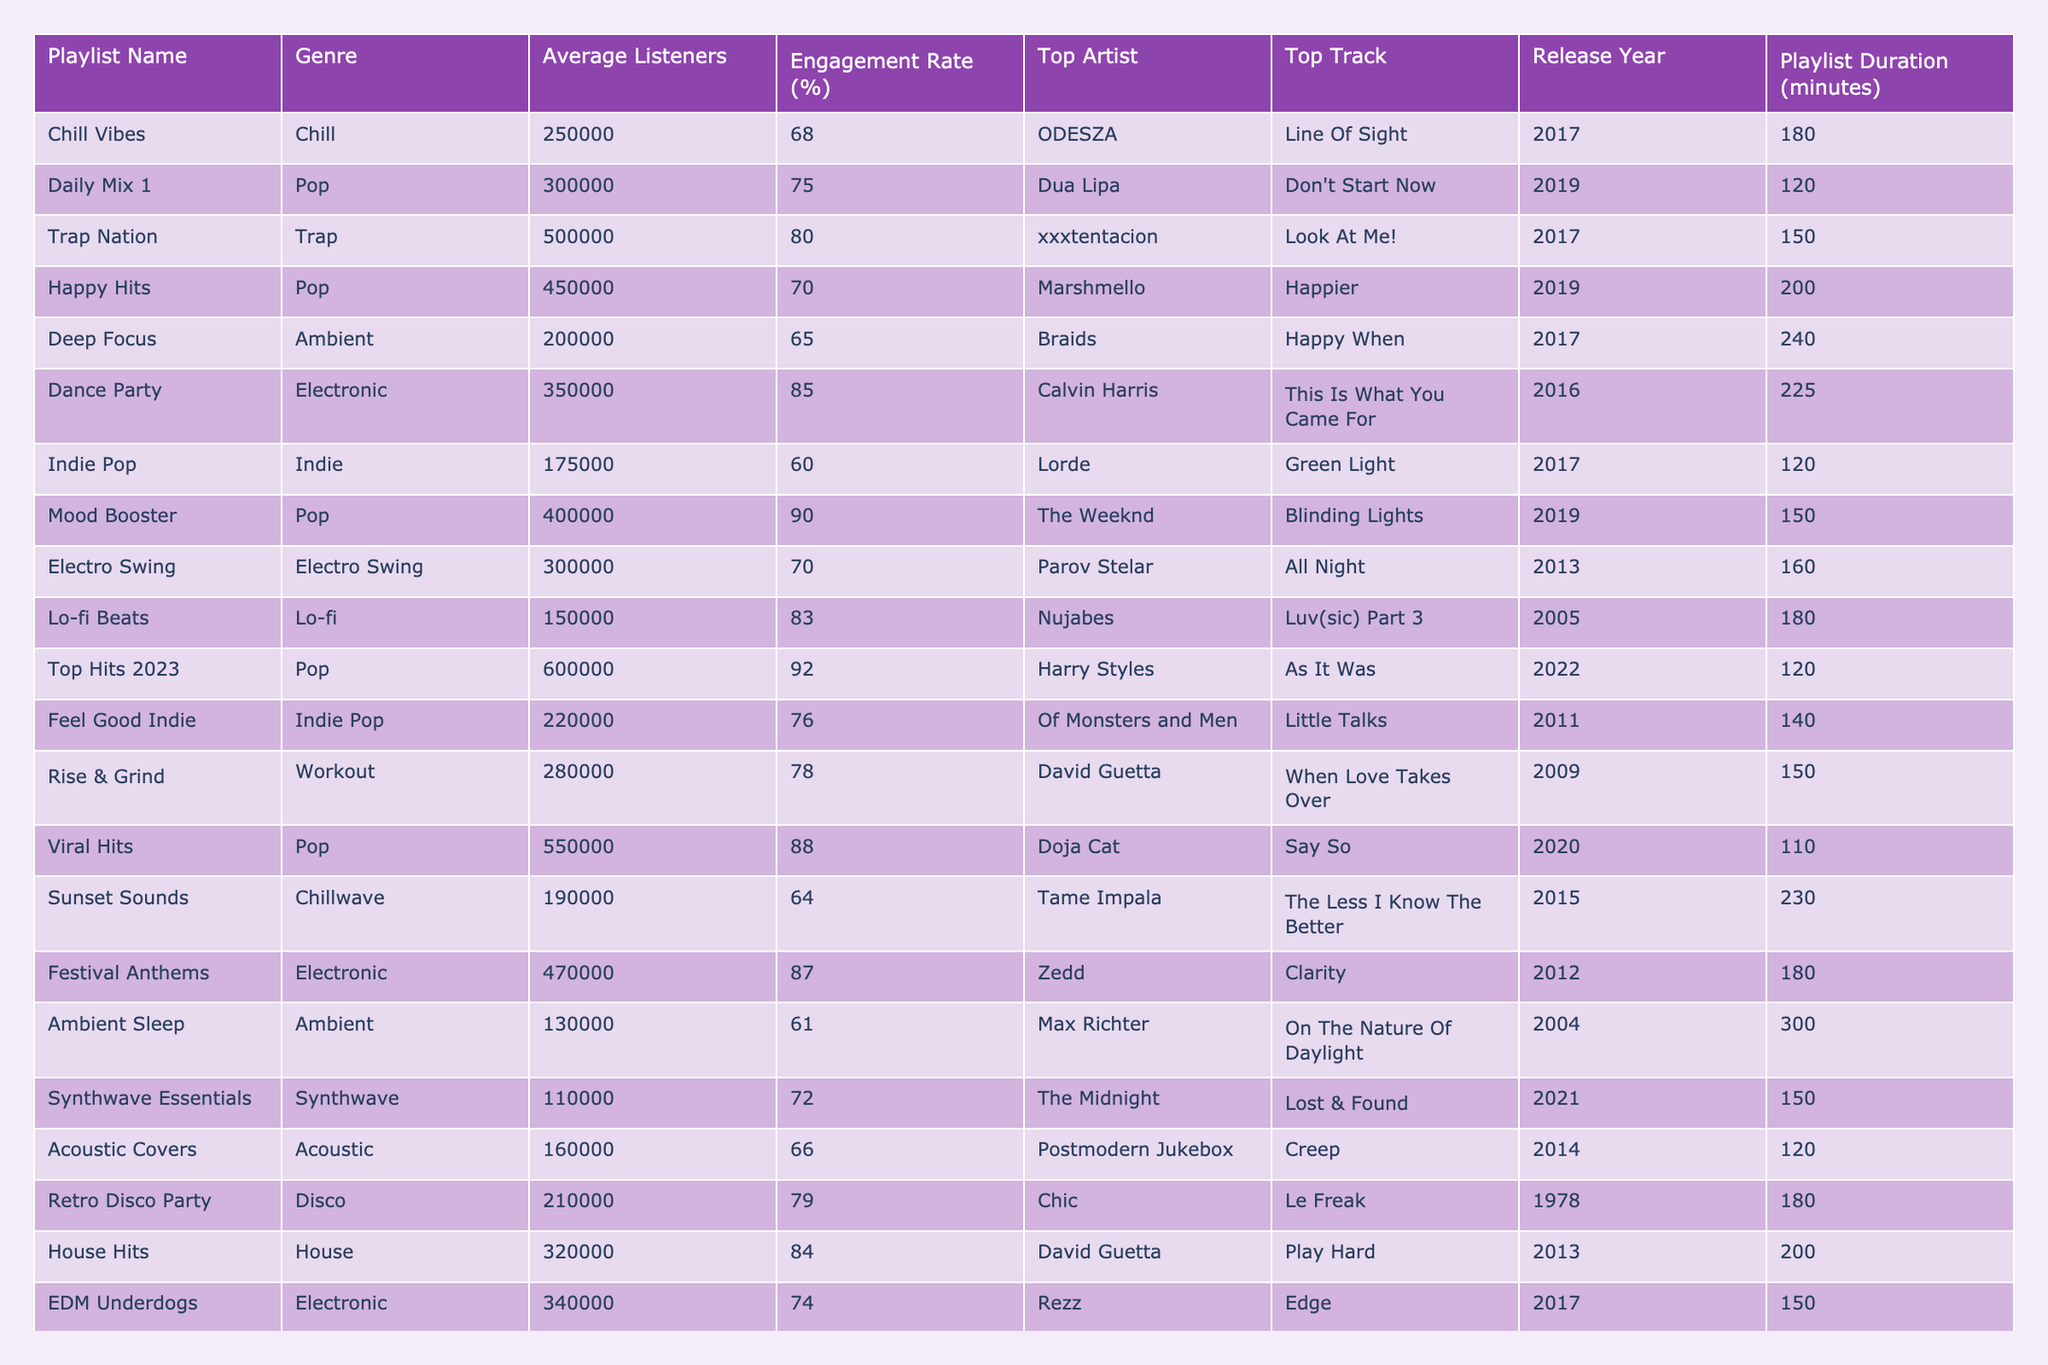What is the average engagement rate of all playlists listed? To find the average engagement rate, sum all the engagement rates (68 + 75 + 80 + 70 + 65 + 85 + 60 + 90 + 70 + 92 + 76 + 78 + 88 + 64 + 87 + 61 + 72 + 66 + 79 + 84 + 74) and divide by the number of playlists, which is 21. The total sum is 1470, so the average engagement rate is 1470 / 21 = 70.0%.
Answer: 70.0% Which playlist has the highest average listeners? By reviewing the "Average Listeners" column, I find that "Top Hits 2023" has the most at 600,000, making it the playlist with the highest average listeners.
Answer: Top Hits 2023 Is the "Mood Booster" playlist genre Pop? Checking the genre of the "Mood Booster" playlist, it is listed as Pop. Therefore, this statement is true.
Answer: True Which playlist has the longest duration and what is its length? By inspecting the "Playlist Duration" column, I see that "Ambient Sleep" has the longest duration at 300 minutes.
Answer: Ambient Sleep, 300 minutes What is the engagement rate difference between "Dance Party" and "Mood Booster"? The engagement rate for "Dance Party" is 85% and for "Mood Booster" it is 90%. The difference is 90 - 85 = 5%.
Answer: 5% Are there any playlists in the Chillwave genre? Looking through the genre column, I can see that there is one playlist named "Sunset Sounds" under the Chillwave genre, so the answer is yes.
Answer: Yes What is the total number of average listeners across all Electronic genre playlists? I calculate the total average listeners by adding the relevant playlists: "Dance Party" (350,000), "Festival Anthems" (470,000), and "EDM Underdogs" (340,000). The total is 350,000 + 470,000 + 340,000 = 1,160,000.
Answer: 1,160,000 Which artist appears most frequently as the top artist in the playlists? By comparing the "Top Artist" entries, I see that David Guetta appears twice: in "Rise & Grind" and "House Hits," making him the most frequently appearing top artist.
Answer: David Guetta What is the average duration of playlists in the Indie genre? The playlists in the Indie genre are "Indie Pop" (120), "Feel Good Indie" (140), and the average duration is (120 + 140) / 2 = 130 minutes.
Answer: 130 minutes What per cent of all playlists have an engagement rate above 80%? Counting the playlists with engagement rates greater than 80%: "Trap Nation," "Mood Booster," "Viral Hits," "Dance Party," and "Festival Anthems," which totals to 5. There are 21 playlists in total, so (5 / 21) * 100 = approximately 23.81%.
Answer: 23.81% 